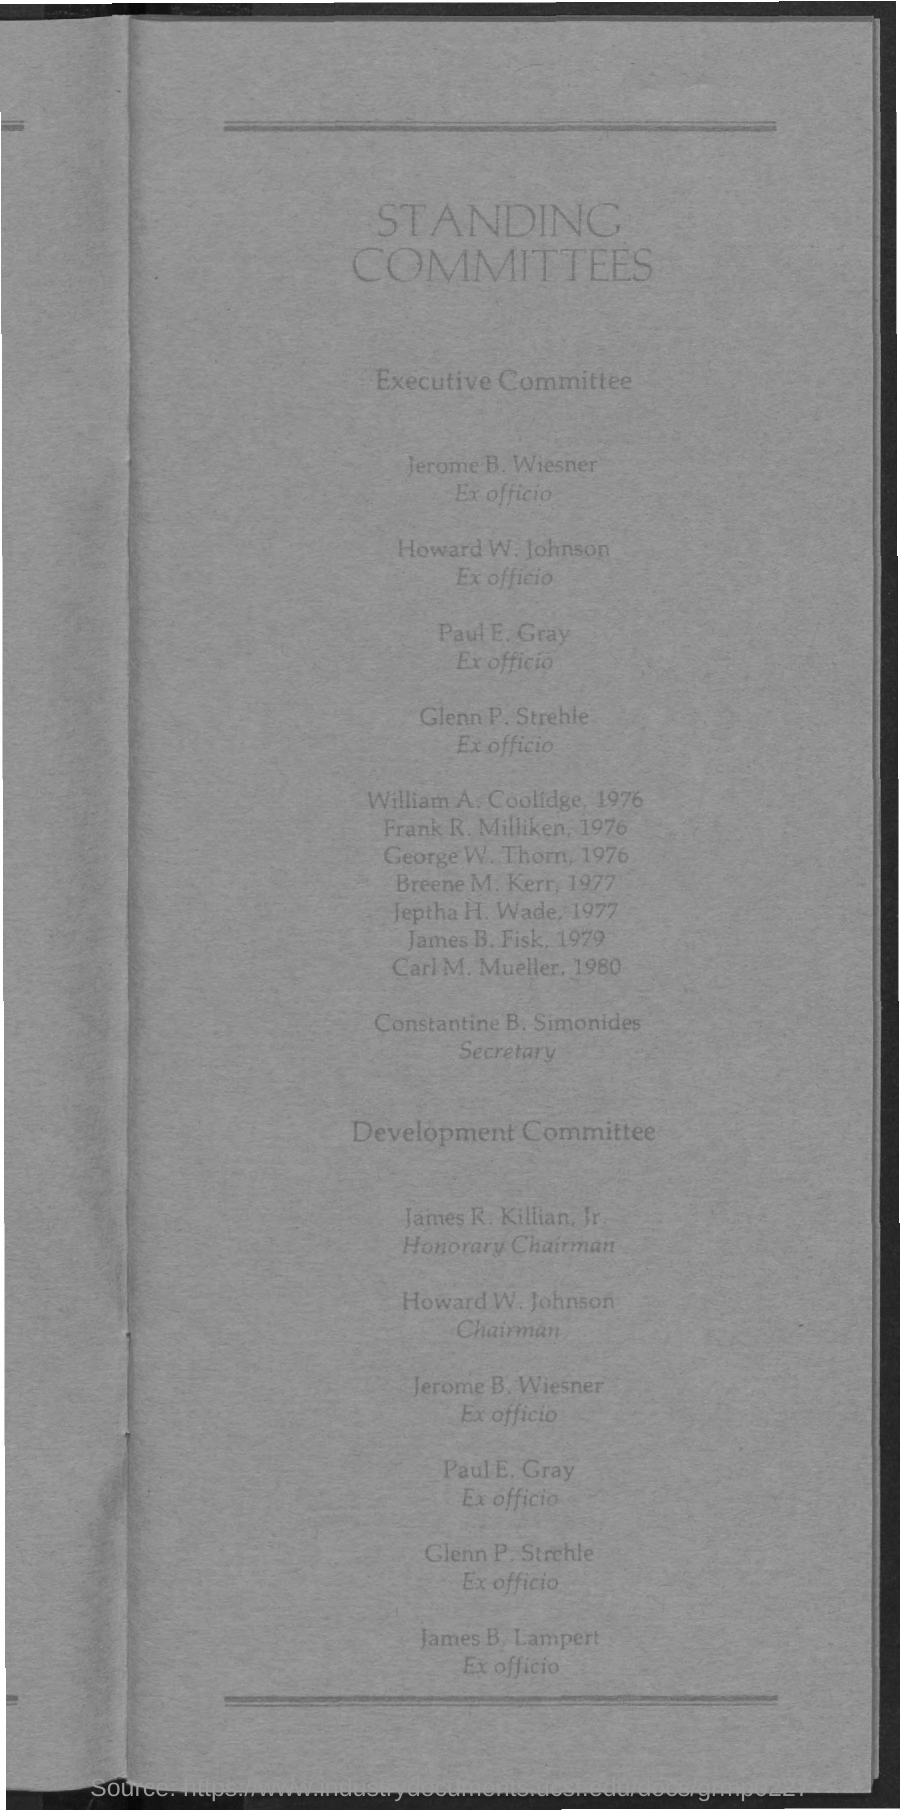List a handful of essential elements in this visual. Paul E. Gray holds the designation of ex-officio. 